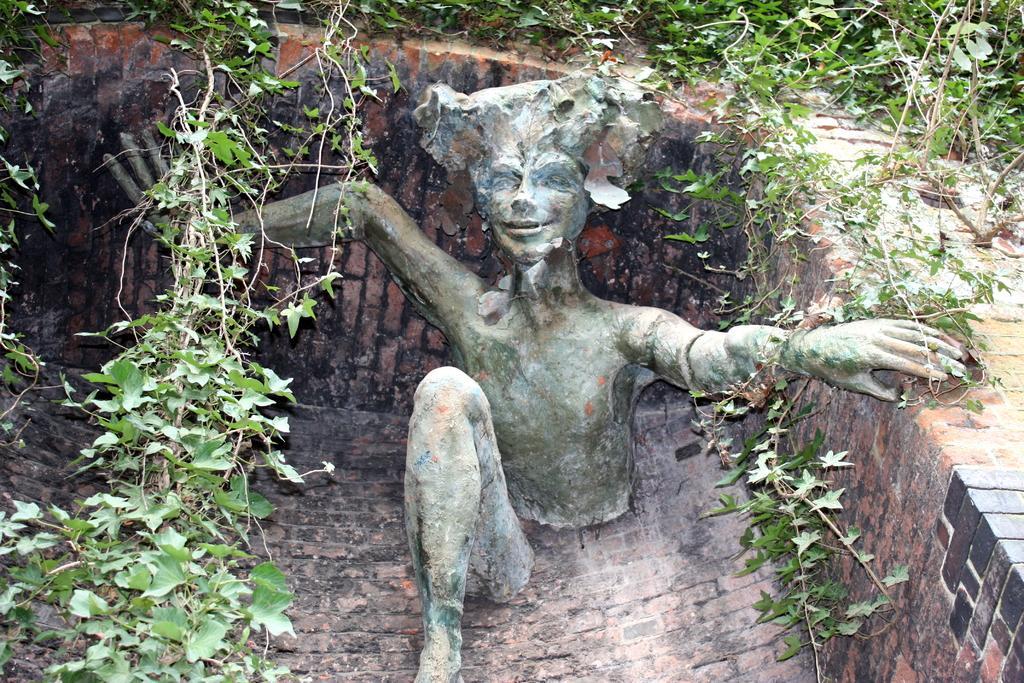Could you give a brief overview of what you see in this image? In this image we can see a sculpture, here is the wall, here is the plant. 